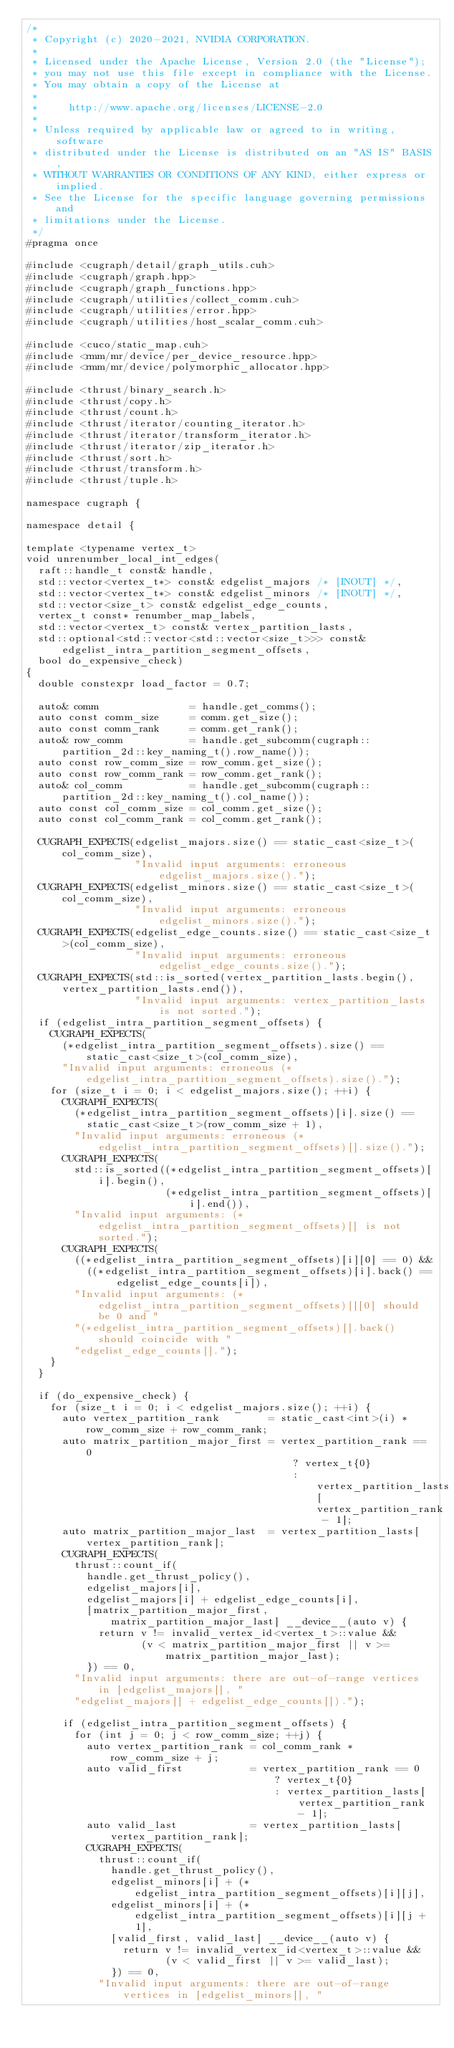<code> <loc_0><loc_0><loc_500><loc_500><_Cuda_>/*
 * Copyright (c) 2020-2021, NVIDIA CORPORATION.
 *
 * Licensed under the Apache License, Version 2.0 (the "License");
 * you may not use this file except in compliance with the License.
 * You may obtain a copy of the License at
 *
 *     http://www.apache.org/licenses/LICENSE-2.0
 *
 * Unless required by applicable law or agreed to in writing, software
 * distributed under the License is distributed on an "AS IS" BASIS,
 * WITHOUT WARRANTIES OR CONDITIONS OF ANY KIND, either express or implied.
 * See the License for the specific language governing permissions and
 * limitations under the License.
 */
#pragma once

#include <cugraph/detail/graph_utils.cuh>
#include <cugraph/graph.hpp>
#include <cugraph/graph_functions.hpp>
#include <cugraph/utilities/collect_comm.cuh>
#include <cugraph/utilities/error.hpp>
#include <cugraph/utilities/host_scalar_comm.cuh>

#include <cuco/static_map.cuh>
#include <rmm/mr/device/per_device_resource.hpp>
#include <rmm/mr/device/polymorphic_allocator.hpp>

#include <thrust/binary_search.h>
#include <thrust/copy.h>
#include <thrust/count.h>
#include <thrust/iterator/counting_iterator.h>
#include <thrust/iterator/transform_iterator.h>
#include <thrust/iterator/zip_iterator.h>
#include <thrust/sort.h>
#include <thrust/transform.h>
#include <thrust/tuple.h>

namespace cugraph {

namespace detail {

template <typename vertex_t>
void unrenumber_local_int_edges(
  raft::handle_t const& handle,
  std::vector<vertex_t*> const& edgelist_majors /* [INOUT] */,
  std::vector<vertex_t*> const& edgelist_minors /* [INOUT] */,
  std::vector<size_t> const& edgelist_edge_counts,
  vertex_t const* renumber_map_labels,
  std::vector<vertex_t> const& vertex_partition_lasts,
  std::optional<std::vector<std::vector<size_t>>> const& edgelist_intra_partition_segment_offsets,
  bool do_expensive_check)
{
  double constexpr load_factor = 0.7;

  auto& comm               = handle.get_comms();
  auto const comm_size     = comm.get_size();
  auto const comm_rank     = comm.get_rank();
  auto& row_comm           = handle.get_subcomm(cugraph::partition_2d::key_naming_t().row_name());
  auto const row_comm_size = row_comm.get_size();
  auto const row_comm_rank = row_comm.get_rank();
  auto& col_comm           = handle.get_subcomm(cugraph::partition_2d::key_naming_t().col_name());
  auto const col_comm_size = col_comm.get_size();
  auto const col_comm_rank = col_comm.get_rank();

  CUGRAPH_EXPECTS(edgelist_majors.size() == static_cast<size_t>(col_comm_size),
                  "Invalid input arguments: erroneous edgelist_majors.size().");
  CUGRAPH_EXPECTS(edgelist_minors.size() == static_cast<size_t>(col_comm_size),
                  "Invalid input arguments: erroneous edgelist_minors.size().");
  CUGRAPH_EXPECTS(edgelist_edge_counts.size() == static_cast<size_t>(col_comm_size),
                  "Invalid input arguments: erroneous edgelist_edge_counts.size().");
  CUGRAPH_EXPECTS(std::is_sorted(vertex_partition_lasts.begin(), vertex_partition_lasts.end()),
                  "Invalid input arguments: vertex_partition_lasts is not sorted.");
  if (edgelist_intra_partition_segment_offsets) {
    CUGRAPH_EXPECTS(
      (*edgelist_intra_partition_segment_offsets).size() == static_cast<size_t>(col_comm_size),
      "Invalid input arguments: erroneous (*edgelist_intra_partition_segment_offsets).size().");
    for (size_t i = 0; i < edgelist_majors.size(); ++i) {
      CUGRAPH_EXPECTS(
        (*edgelist_intra_partition_segment_offsets)[i].size() ==
          static_cast<size_t>(row_comm_size + 1),
        "Invalid input arguments: erroneous (*edgelist_intra_partition_segment_offsets)[].size().");
      CUGRAPH_EXPECTS(
        std::is_sorted((*edgelist_intra_partition_segment_offsets)[i].begin(),
                       (*edgelist_intra_partition_segment_offsets)[i].end()),
        "Invalid input arguments: (*edgelist_intra_partition_segment_offsets)[] is not sorted.");
      CUGRAPH_EXPECTS(
        ((*edgelist_intra_partition_segment_offsets)[i][0] == 0) &&
          ((*edgelist_intra_partition_segment_offsets)[i].back() == edgelist_edge_counts[i]),
        "Invalid input arguments: (*edgelist_intra_partition_segment_offsets)[][0] should be 0 and "
        "(*edgelist_intra_partition_segment_offsets)[].back() should coincide with "
        "edgelist_edge_counts[].");
    }
  }

  if (do_expensive_check) {
    for (size_t i = 0; i < edgelist_majors.size(); ++i) {
      auto vertex_partition_rank        = static_cast<int>(i) * row_comm_size + row_comm_rank;
      auto matrix_partition_major_first = vertex_partition_rank == 0
                                            ? vertex_t{0}
                                            : vertex_partition_lasts[vertex_partition_rank - 1];
      auto matrix_partition_major_last  = vertex_partition_lasts[vertex_partition_rank];
      CUGRAPH_EXPECTS(
        thrust::count_if(
          handle.get_thrust_policy(),
          edgelist_majors[i],
          edgelist_majors[i] + edgelist_edge_counts[i],
          [matrix_partition_major_first, matrix_partition_major_last] __device__(auto v) {
            return v != invalid_vertex_id<vertex_t>::value &&
                   (v < matrix_partition_major_first || v >= matrix_partition_major_last);
          }) == 0,
        "Invalid input arguments: there are out-of-range vertices in [edgelist_majors[], "
        "edgelist_majors[] + edgelist_edge_counts[]).");

      if (edgelist_intra_partition_segment_offsets) {
        for (int j = 0; j < row_comm_size; ++j) {
          auto vertex_partition_rank = col_comm_rank * row_comm_size + j;
          auto valid_first           = vertex_partition_rank == 0
                                         ? vertex_t{0}
                                         : vertex_partition_lasts[vertex_partition_rank - 1];
          auto valid_last            = vertex_partition_lasts[vertex_partition_rank];
          CUGRAPH_EXPECTS(
            thrust::count_if(
              handle.get_thrust_policy(),
              edgelist_minors[i] + (*edgelist_intra_partition_segment_offsets)[i][j],
              edgelist_minors[i] + (*edgelist_intra_partition_segment_offsets)[i][j + 1],
              [valid_first, valid_last] __device__(auto v) {
                return v != invalid_vertex_id<vertex_t>::value &&
                       (v < valid_first || v >= valid_last);
              }) == 0,
            "Invalid input arguments: there are out-of-range vertices in [edgelist_minors[], "</code> 